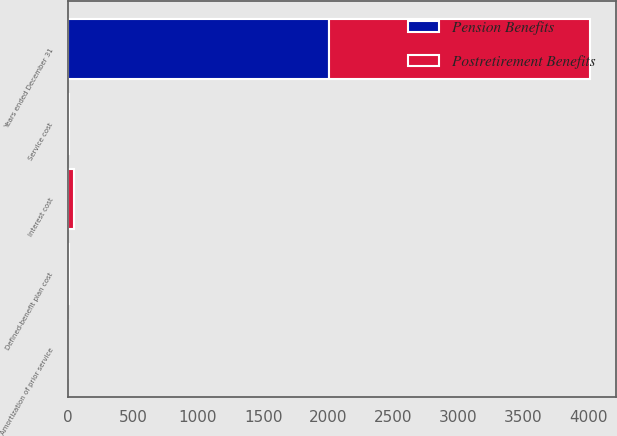Convert chart to OTSL. <chart><loc_0><loc_0><loc_500><loc_500><stacked_bar_chart><ecel><fcel>Years ended December 31<fcel>Service cost<fcel>Interest cost<fcel>Amortization of prior service<fcel>Defined-benefit plan cost<nl><fcel>Postretirement Benefits<fcel>2003<fcel>7.5<fcel>46.8<fcel>0.4<fcel>11.6<nl><fcel>Pension Benefits<fcel>2003<fcel>0.2<fcel>1.1<fcel>0.2<fcel>1.1<nl></chart> 